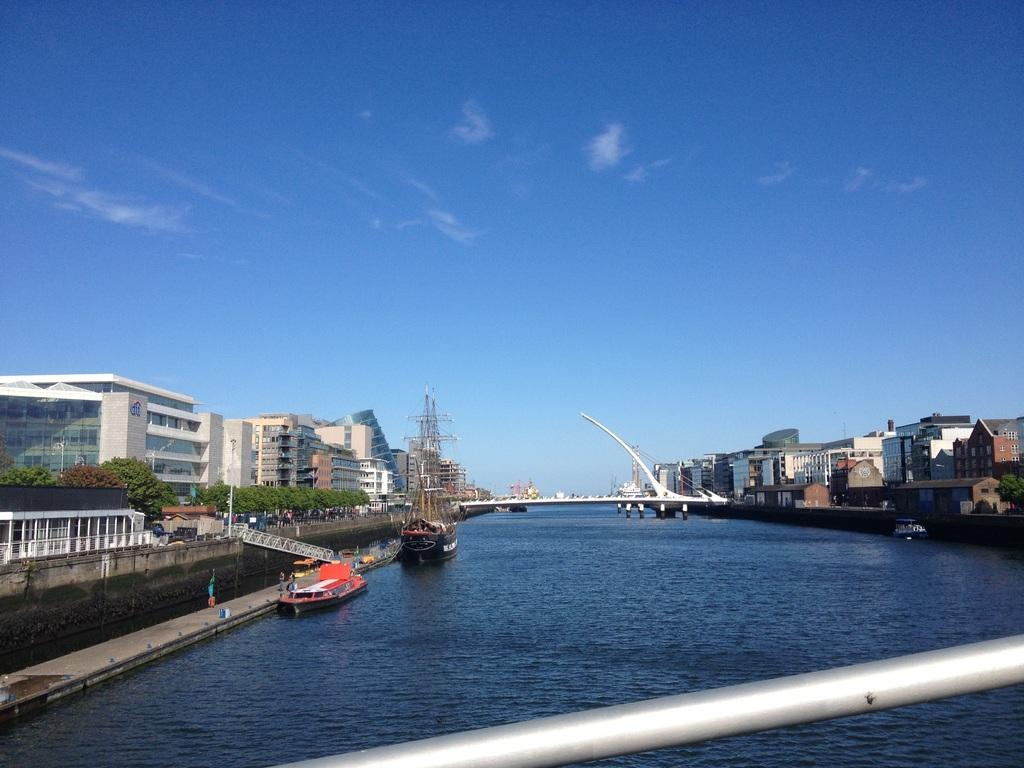What type of structures can be seen in the image? There are buildings in the image. What natural elements are present in the image? There are trees in the image. What mode of transportation can be seen in the image? There are ships in the image. What is the primary body of water in the image? There is water visible in the image. What type of man-made structure connects two areas in the image? There is a bridge in the image. What is the color of the sky in the image? The sky is blue and white in color. Can you see a club being used to hit a ball in the image? There is no club or ball present in the image. How many pieces of pie can be seen on the bridge in the image? There is no pie present in the image, and the bridge is not a location where pie would typically be found. 